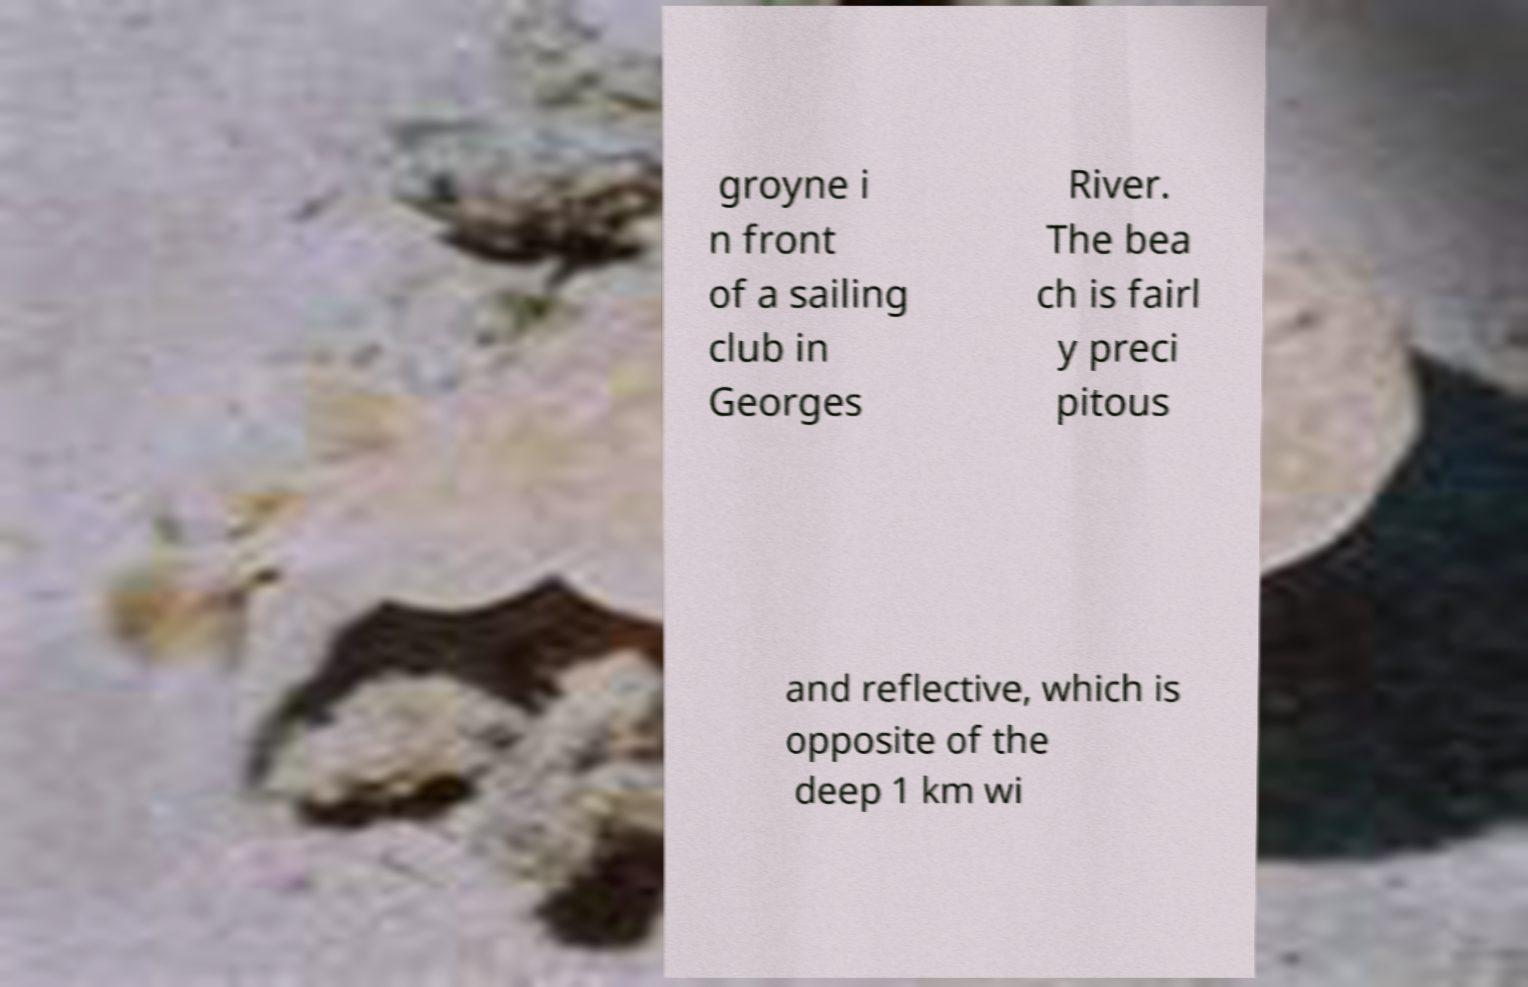I need the written content from this picture converted into text. Can you do that? groyne i n front of a sailing club in Georges River. The bea ch is fairl y preci pitous and reflective, which is opposite of the deep 1 km wi 